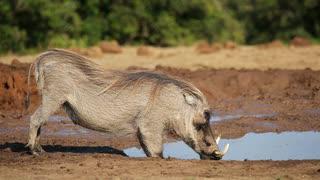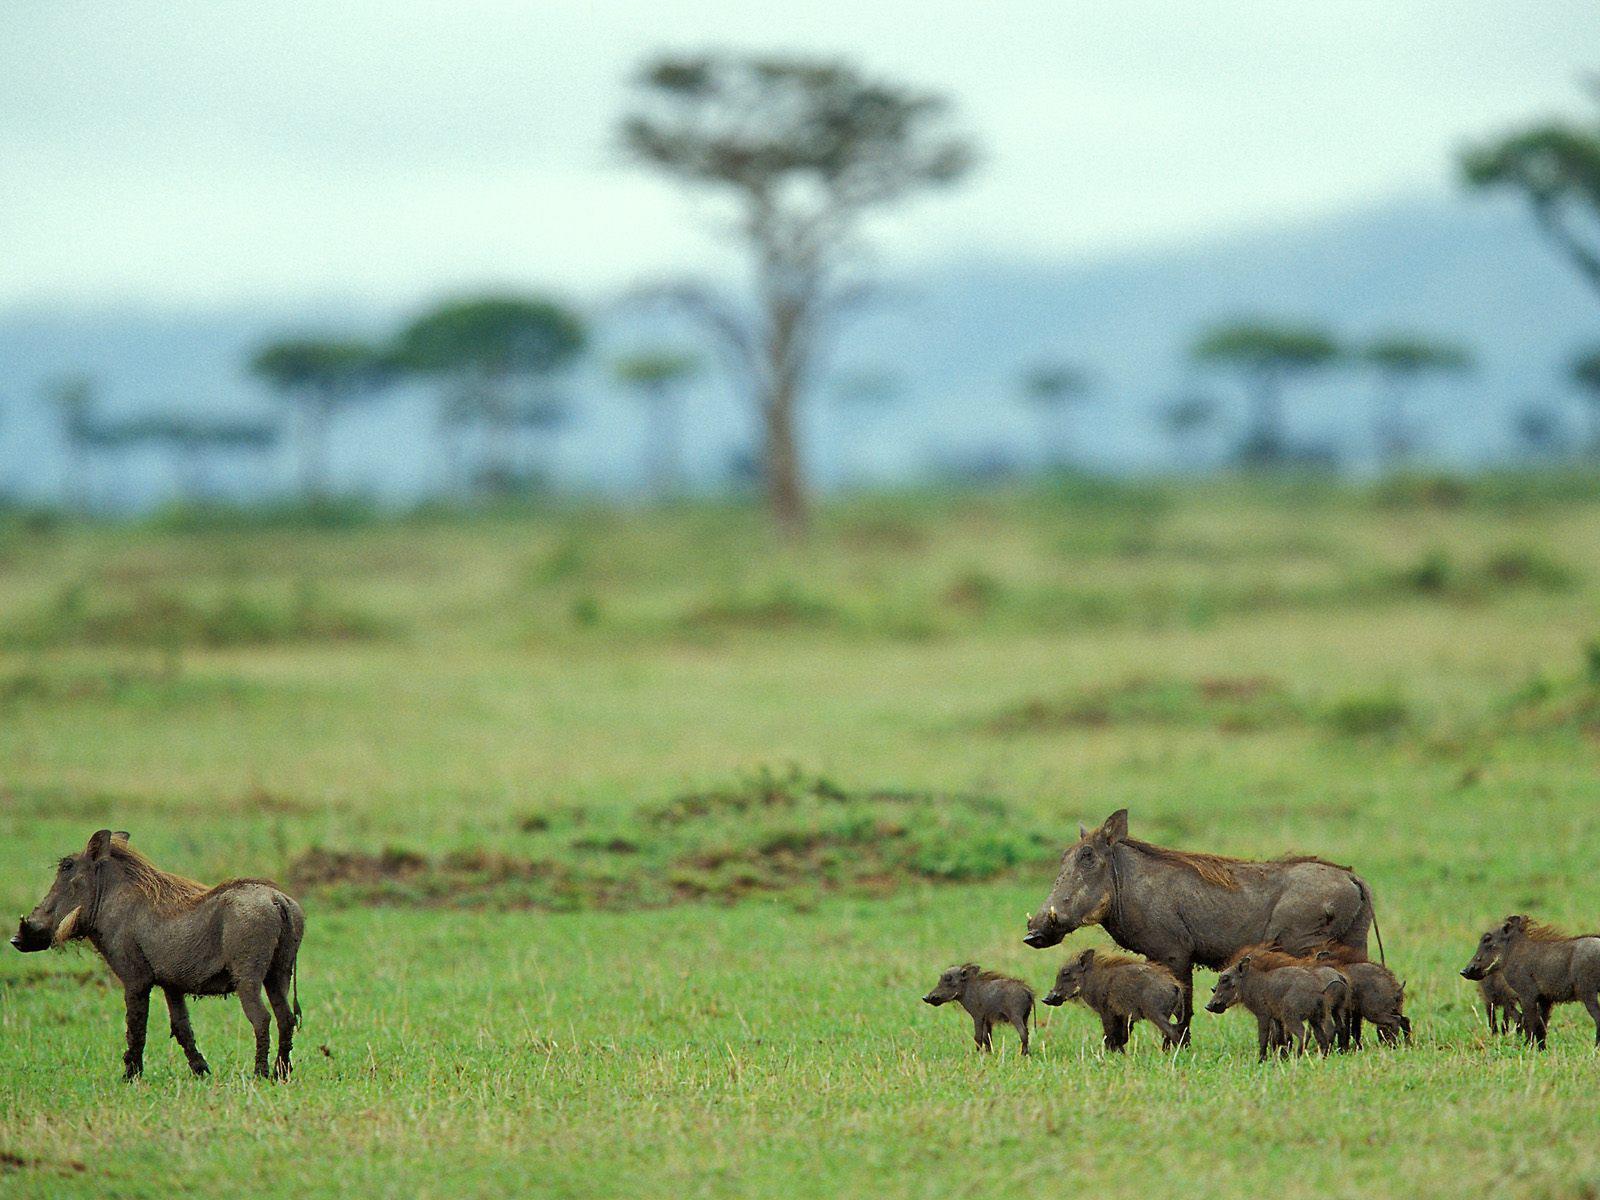The first image is the image on the left, the second image is the image on the right. Assess this claim about the two images: "Multiple warthogs stand at the edge of a muddy hole.". Correct or not? Answer yes or no. No. The first image is the image on the left, the second image is the image on the right. Evaluate the accuracy of this statement regarding the images: "There is no more than one warthog in the left image.". Is it true? Answer yes or no. Yes. 